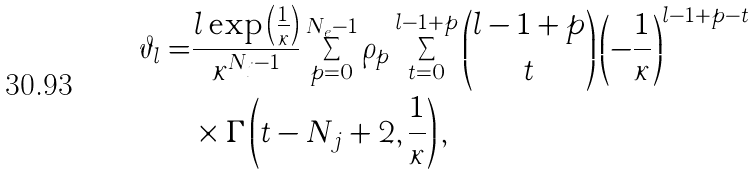<formula> <loc_0><loc_0><loc_500><loc_500>\vartheta _ { l } = & \frac { l \exp \left ( \frac { 1 } { \kappa } \right ) } { \kappa ^ { N _ { j } - 1 } } \sum _ { p = 0 } ^ { N _ { e } - 1 } \rho _ { p } \sum _ { t = 0 } ^ { l - 1 + p } { l - 1 + p \choose t } \left ( - \frac { 1 } { \kappa } \right ) ^ { l - 1 + p - t } \\ & \times \Gamma \left ( t - N _ { j } + 2 , \frac { 1 } { \kappa } \right ) ,</formula> 